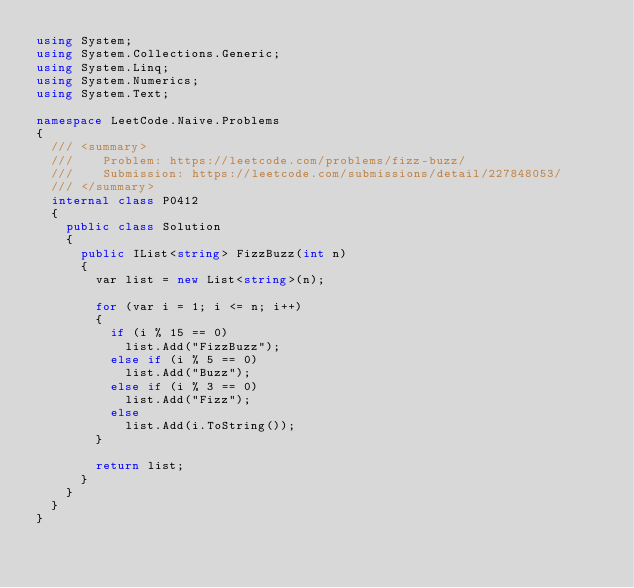<code> <loc_0><loc_0><loc_500><loc_500><_C#_>using System;
using System.Collections.Generic;
using System.Linq;
using System.Numerics;
using System.Text;

namespace LeetCode.Naive.Problems
{
  /// <summary>
  ///    Problem: https://leetcode.com/problems/fizz-buzz/
  ///    Submission: https://leetcode.com/submissions/detail/227848053/
  /// </summary>
  internal class P0412
  {
    public class Solution
    {
      public IList<string> FizzBuzz(int n)
      {
        var list = new List<string>(n);

        for (var i = 1; i <= n; i++)
        {
          if (i % 15 == 0)
            list.Add("FizzBuzz");
          else if (i % 5 == 0)
            list.Add("Buzz");
          else if (i % 3 == 0)
            list.Add("Fizz");
          else
            list.Add(i.ToString());
        }

        return list;
      }
    }
  }
}
</code> 